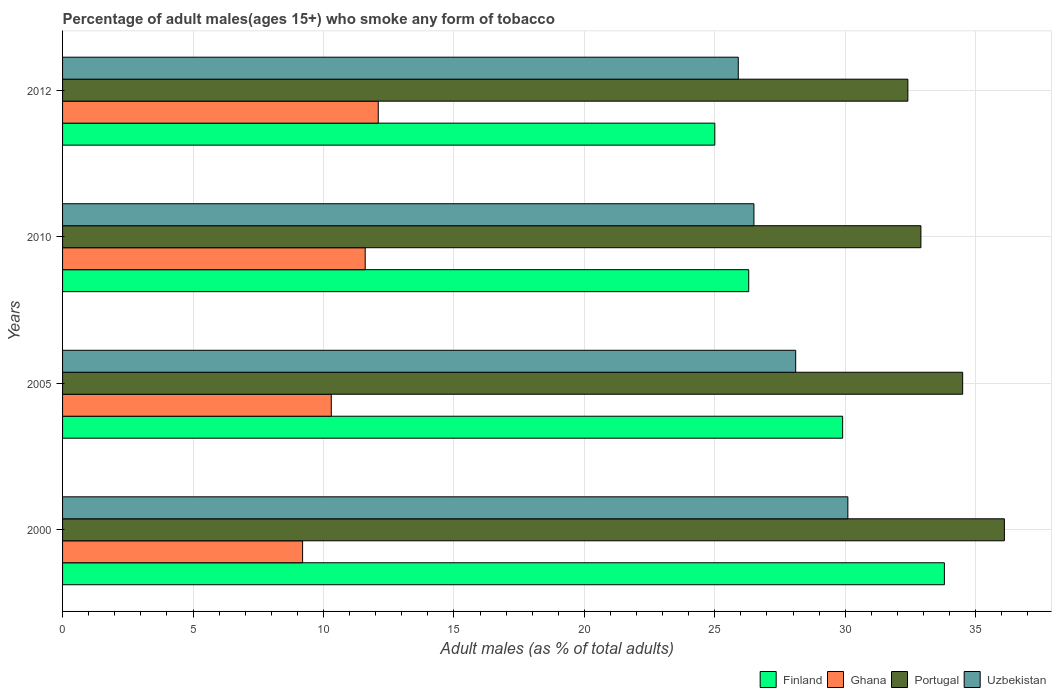Are the number of bars per tick equal to the number of legend labels?
Your answer should be compact. Yes. Are the number of bars on each tick of the Y-axis equal?
Provide a short and direct response. Yes. How many bars are there on the 2nd tick from the top?
Your answer should be compact. 4. How many bars are there on the 3rd tick from the bottom?
Keep it short and to the point. 4. Across all years, what is the minimum percentage of adult males who smoke in Uzbekistan?
Make the answer very short. 25.9. What is the total percentage of adult males who smoke in Finland in the graph?
Offer a very short reply. 115. What is the difference between the percentage of adult males who smoke in Uzbekistan in 2005 and that in 2012?
Offer a terse response. 2.2. What is the difference between the percentage of adult males who smoke in Ghana in 2010 and the percentage of adult males who smoke in Finland in 2000?
Your answer should be compact. -22.2. In the year 2000, what is the difference between the percentage of adult males who smoke in Ghana and percentage of adult males who smoke in Portugal?
Ensure brevity in your answer.  -26.9. What is the ratio of the percentage of adult males who smoke in Uzbekistan in 2010 to that in 2012?
Offer a very short reply. 1.02. Is the percentage of adult males who smoke in Ghana in 2000 less than that in 2005?
Your answer should be very brief. Yes. What is the difference between the highest and the second highest percentage of adult males who smoke in Finland?
Your answer should be very brief. 3.9. What is the difference between the highest and the lowest percentage of adult males who smoke in Portugal?
Offer a terse response. 3.7. Is the sum of the percentage of adult males who smoke in Portugal in 2000 and 2005 greater than the maximum percentage of adult males who smoke in Finland across all years?
Ensure brevity in your answer.  Yes. What does the 3rd bar from the bottom in 2000 represents?
Ensure brevity in your answer.  Portugal. How many bars are there?
Provide a succinct answer. 16. Are all the bars in the graph horizontal?
Keep it short and to the point. Yes. How many years are there in the graph?
Offer a very short reply. 4. What is the difference between two consecutive major ticks on the X-axis?
Ensure brevity in your answer.  5. Are the values on the major ticks of X-axis written in scientific E-notation?
Give a very brief answer. No. Does the graph contain any zero values?
Make the answer very short. No. Does the graph contain grids?
Give a very brief answer. Yes. Where does the legend appear in the graph?
Provide a short and direct response. Bottom right. How many legend labels are there?
Your answer should be compact. 4. What is the title of the graph?
Provide a short and direct response. Percentage of adult males(ages 15+) who smoke any form of tobacco. What is the label or title of the X-axis?
Give a very brief answer. Adult males (as % of total adults). What is the label or title of the Y-axis?
Keep it short and to the point. Years. What is the Adult males (as % of total adults) of Finland in 2000?
Offer a terse response. 33.8. What is the Adult males (as % of total adults) of Portugal in 2000?
Ensure brevity in your answer.  36.1. What is the Adult males (as % of total adults) of Uzbekistan in 2000?
Offer a very short reply. 30.1. What is the Adult males (as % of total adults) of Finland in 2005?
Offer a very short reply. 29.9. What is the Adult males (as % of total adults) of Portugal in 2005?
Your answer should be compact. 34.5. What is the Adult males (as % of total adults) of Uzbekistan in 2005?
Give a very brief answer. 28.1. What is the Adult males (as % of total adults) in Finland in 2010?
Give a very brief answer. 26.3. What is the Adult males (as % of total adults) of Portugal in 2010?
Your answer should be very brief. 32.9. What is the Adult males (as % of total adults) of Uzbekistan in 2010?
Offer a very short reply. 26.5. What is the Adult males (as % of total adults) of Ghana in 2012?
Your response must be concise. 12.1. What is the Adult males (as % of total adults) of Portugal in 2012?
Your response must be concise. 32.4. What is the Adult males (as % of total adults) of Uzbekistan in 2012?
Make the answer very short. 25.9. Across all years, what is the maximum Adult males (as % of total adults) in Finland?
Provide a short and direct response. 33.8. Across all years, what is the maximum Adult males (as % of total adults) in Portugal?
Make the answer very short. 36.1. Across all years, what is the maximum Adult males (as % of total adults) in Uzbekistan?
Ensure brevity in your answer.  30.1. Across all years, what is the minimum Adult males (as % of total adults) of Ghana?
Offer a terse response. 9.2. Across all years, what is the minimum Adult males (as % of total adults) of Portugal?
Provide a succinct answer. 32.4. Across all years, what is the minimum Adult males (as % of total adults) of Uzbekistan?
Your answer should be very brief. 25.9. What is the total Adult males (as % of total adults) in Finland in the graph?
Offer a very short reply. 115. What is the total Adult males (as % of total adults) of Ghana in the graph?
Keep it short and to the point. 43.2. What is the total Adult males (as % of total adults) of Portugal in the graph?
Offer a very short reply. 135.9. What is the total Adult males (as % of total adults) of Uzbekistan in the graph?
Your answer should be compact. 110.6. What is the difference between the Adult males (as % of total adults) in Finland in 2000 and that in 2005?
Make the answer very short. 3.9. What is the difference between the Adult males (as % of total adults) of Ghana in 2000 and that in 2005?
Make the answer very short. -1.1. What is the difference between the Adult males (as % of total adults) of Portugal in 2000 and that in 2005?
Keep it short and to the point. 1.6. What is the difference between the Adult males (as % of total adults) in Uzbekistan in 2000 and that in 2005?
Ensure brevity in your answer.  2. What is the difference between the Adult males (as % of total adults) in Portugal in 2000 and that in 2010?
Ensure brevity in your answer.  3.2. What is the difference between the Adult males (as % of total adults) of Uzbekistan in 2000 and that in 2010?
Provide a succinct answer. 3.6. What is the difference between the Adult males (as % of total adults) in Finland in 2000 and that in 2012?
Provide a short and direct response. 8.8. What is the difference between the Adult males (as % of total adults) of Ghana in 2000 and that in 2012?
Your response must be concise. -2.9. What is the difference between the Adult males (as % of total adults) of Uzbekistan in 2000 and that in 2012?
Ensure brevity in your answer.  4.2. What is the difference between the Adult males (as % of total adults) of Finland in 2005 and that in 2012?
Your answer should be compact. 4.9. What is the difference between the Adult males (as % of total adults) in Ghana in 2005 and that in 2012?
Keep it short and to the point. -1.8. What is the difference between the Adult males (as % of total adults) of Portugal in 2005 and that in 2012?
Provide a succinct answer. 2.1. What is the difference between the Adult males (as % of total adults) in Uzbekistan in 2005 and that in 2012?
Your answer should be compact. 2.2. What is the difference between the Adult males (as % of total adults) of Portugal in 2010 and that in 2012?
Your response must be concise. 0.5. What is the difference between the Adult males (as % of total adults) of Uzbekistan in 2010 and that in 2012?
Offer a very short reply. 0.6. What is the difference between the Adult males (as % of total adults) in Finland in 2000 and the Adult males (as % of total adults) in Ghana in 2005?
Your answer should be compact. 23.5. What is the difference between the Adult males (as % of total adults) in Finland in 2000 and the Adult males (as % of total adults) in Uzbekistan in 2005?
Your answer should be compact. 5.7. What is the difference between the Adult males (as % of total adults) in Ghana in 2000 and the Adult males (as % of total adults) in Portugal in 2005?
Your answer should be compact. -25.3. What is the difference between the Adult males (as % of total adults) of Ghana in 2000 and the Adult males (as % of total adults) of Uzbekistan in 2005?
Provide a short and direct response. -18.9. What is the difference between the Adult males (as % of total adults) of Finland in 2000 and the Adult males (as % of total adults) of Ghana in 2010?
Offer a very short reply. 22.2. What is the difference between the Adult males (as % of total adults) in Finland in 2000 and the Adult males (as % of total adults) in Uzbekistan in 2010?
Your answer should be very brief. 7.3. What is the difference between the Adult males (as % of total adults) of Ghana in 2000 and the Adult males (as % of total adults) of Portugal in 2010?
Provide a succinct answer. -23.7. What is the difference between the Adult males (as % of total adults) in Ghana in 2000 and the Adult males (as % of total adults) in Uzbekistan in 2010?
Offer a terse response. -17.3. What is the difference between the Adult males (as % of total adults) of Finland in 2000 and the Adult males (as % of total adults) of Ghana in 2012?
Make the answer very short. 21.7. What is the difference between the Adult males (as % of total adults) of Finland in 2000 and the Adult males (as % of total adults) of Portugal in 2012?
Offer a terse response. 1.4. What is the difference between the Adult males (as % of total adults) of Ghana in 2000 and the Adult males (as % of total adults) of Portugal in 2012?
Offer a very short reply. -23.2. What is the difference between the Adult males (as % of total adults) in Ghana in 2000 and the Adult males (as % of total adults) in Uzbekistan in 2012?
Your answer should be very brief. -16.7. What is the difference between the Adult males (as % of total adults) of Portugal in 2000 and the Adult males (as % of total adults) of Uzbekistan in 2012?
Your answer should be compact. 10.2. What is the difference between the Adult males (as % of total adults) in Finland in 2005 and the Adult males (as % of total adults) in Uzbekistan in 2010?
Your response must be concise. 3.4. What is the difference between the Adult males (as % of total adults) of Ghana in 2005 and the Adult males (as % of total adults) of Portugal in 2010?
Give a very brief answer. -22.6. What is the difference between the Adult males (as % of total adults) in Ghana in 2005 and the Adult males (as % of total adults) in Uzbekistan in 2010?
Ensure brevity in your answer.  -16.2. What is the difference between the Adult males (as % of total adults) in Finland in 2005 and the Adult males (as % of total adults) in Ghana in 2012?
Ensure brevity in your answer.  17.8. What is the difference between the Adult males (as % of total adults) of Finland in 2005 and the Adult males (as % of total adults) of Uzbekistan in 2012?
Offer a very short reply. 4. What is the difference between the Adult males (as % of total adults) of Ghana in 2005 and the Adult males (as % of total adults) of Portugal in 2012?
Offer a terse response. -22.1. What is the difference between the Adult males (as % of total adults) in Ghana in 2005 and the Adult males (as % of total adults) in Uzbekistan in 2012?
Offer a terse response. -15.6. What is the difference between the Adult males (as % of total adults) of Portugal in 2005 and the Adult males (as % of total adults) of Uzbekistan in 2012?
Make the answer very short. 8.6. What is the difference between the Adult males (as % of total adults) in Ghana in 2010 and the Adult males (as % of total adults) in Portugal in 2012?
Keep it short and to the point. -20.8. What is the difference between the Adult males (as % of total adults) in Ghana in 2010 and the Adult males (as % of total adults) in Uzbekistan in 2012?
Keep it short and to the point. -14.3. What is the difference between the Adult males (as % of total adults) of Portugal in 2010 and the Adult males (as % of total adults) of Uzbekistan in 2012?
Provide a succinct answer. 7. What is the average Adult males (as % of total adults) in Finland per year?
Your answer should be very brief. 28.75. What is the average Adult males (as % of total adults) of Portugal per year?
Your answer should be compact. 33.98. What is the average Adult males (as % of total adults) of Uzbekistan per year?
Offer a terse response. 27.65. In the year 2000, what is the difference between the Adult males (as % of total adults) in Finland and Adult males (as % of total adults) in Ghana?
Ensure brevity in your answer.  24.6. In the year 2000, what is the difference between the Adult males (as % of total adults) in Ghana and Adult males (as % of total adults) in Portugal?
Keep it short and to the point. -26.9. In the year 2000, what is the difference between the Adult males (as % of total adults) in Ghana and Adult males (as % of total adults) in Uzbekistan?
Keep it short and to the point. -20.9. In the year 2005, what is the difference between the Adult males (as % of total adults) of Finland and Adult males (as % of total adults) of Ghana?
Your answer should be very brief. 19.6. In the year 2005, what is the difference between the Adult males (as % of total adults) of Finland and Adult males (as % of total adults) of Portugal?
Offer a terse response. -4.6. In the year 2005, what is the difference between the Adult males (as % of total adults) in Ghana and Adult males (as % of total adults) in Portugal?
Make the answer very short. -24.2. In the year 2005, what is the difference between the Adult males (as % of total adults) in Ghana and Adult males (as % of total adults) in Uzbekistan?
Give a very brief answer. -17.8. In the year 2010, what is the difference between the Adult males (as % of total adults) of Finland and Adult males (as % of total adults) of Ghana?
Offer a terse response. 14.7. In the year 2010, what is the difference between the Adult males (as % of total adults) of Ghana and Adult males (as % of total adults) of Portugal?
Your response must be concise. -21.3. In the year 2010, what is the difference between the Adult males (as % of total adults) of Ghana and Adult males (as % of total adults) of Uzbekistan?
Keep it short and to the point. -14.9. In the year 2012, what is the difference between the Adult males (as % of total adults) in Finland and Adult males (as % of total adults) in Ghana?
Keep it short and to the point. 12.9. In the year 2012, what is the difference between the Adult males (as % of total adults) of Finland and Adult males (as % of total adults) of Portugal?
Your response must be concise. -7.4. In the year 2012, what is the difference between the Adult males (as % of total adults) in Ghana and Adult males (as % of total adults) in Portugal?
Keep it short and to the point. -20.3. What is the ratio of the Adult males (as % of total adults) of Finland in 2000 to that in 2005?
Provide a short and direct response. 1.13. What is the ratio of the Adult males (as % of total adults) of Ghana in 2000 to that in 2005?
Keep it short and to the point. 0.89. What is the ratio of the Adult males (as % of total adults) in Portugal in 2000 to that in 2005?
Your answer should be very brief. 1.05. What is the ratio of the Adult males (as % of total adults) in Uzbekistan in 2000 to that in 2005?
Your response must be concise. 1.07. What is the ratio of the Adult males (as % of total adults) in Finland in 2000 to that in 2010?
Your response must be concise. 1.29. What is the ratio of the Adult males (as % of total adults) of Ghana in 2000 to that in 2010?
Give a very brief answer. 0.79. What is the ratio of the Adult males (as % of total adults) in Portugal in 2000 to that in 2010?
Make the answer very short. 1.1. What is the ratio of the Adult males (as % of total adults) of Uzbekistan in 2000 to that in 2010?
Make the answer very short. 1.14. What is the ratio of the Adult males (as % of total adults) in Finland in 2000 to that in 2012?
Ensure brevity in your answer.  1.35. What is the ratio of the Adult males (as % of total adults) in Ghana in 2000 to that in 2012?
Your response must be concise. 0.76. What is the ratio of the Adult males (as % of total adults) in Portugal in 2000 to that in 2012?
Provide a succinct answer. 1.11. What is the ratio of the Adult males (as % of total adults) in Uzbekistan in 2000 to that in 2012?
Keep it short and to the point. 1.16. What is the ratio of the Adult males (as % of total adults) in Finland in 2005 to that in 2010?
Give a very brief answer. 1.14. What is the ratio of the Adult males (as % of total adults) in Ghana in 2005 to that in 2010?
Your answer should be compact. 0.89. What is the ratio of the Adult males (as % of total adults) of Portugal in 2005 to that in 2010?
Provide a succinct answer. 1.05. What is the ratio of the Adult males (as % of total adults) in Uzbekistan in 2005 to that in 2010?
Keep it short and to the point. 1.06. What is the ratio of the Adult males (as % of total adults) in Finland in 2005 to that in 2012?
Provide a succinct answer. 1.2. What is the ratio of the Adult males (as % of total adults) of Ghana in 2005 to that in 2012?
Your answer should be compact. 0.85. What is the ratio of the Adult males (as % of total adults) in Portugal in 2005 to that in 2012?
Give a very brief answer. 1.06. What is the ratio of the Adult males (as % of total adults) of Uzbekistan in 2005 to that in 2012?
Keep it short and to the point. 1.08. What is the ratio of the Adult males (as % of total adults) of Finland in 2010 to that in 2012?
Offer a terse response. 1.05. What is the ratio of the Adult males (as % of total adults) in Ghana in 2010 to that in 2012?
Give a very brief answer. 0.96. What is the ratio of the Adult males (as % of total adults) in Portugal in 2010 to that in 2012?
Your answer should be compact. 1.02. What is the ratio of the Adult males (as % of total adults) in Uzbekistan in 2010 to that in 2012?
Provide a succinct answer. 1.02. What is the difference between the highest and the second highest Adult males (as % of total adults) in Ghana?
Provide a succinct answer. 0.5. What is the difference between the highest and the second highest Adult males (as % of total adults) of Portugal?
Keep it short and to the point. 1.6. What is the difference between the highest and the lowest Adult males (as % of total adults) of Finland?
Provide a short and direct response. 8.8. What is the difference between the highest and the lowest Adult males (as % of total adults) in Uzbekistan?
Offer a very short reply. 4.2. 